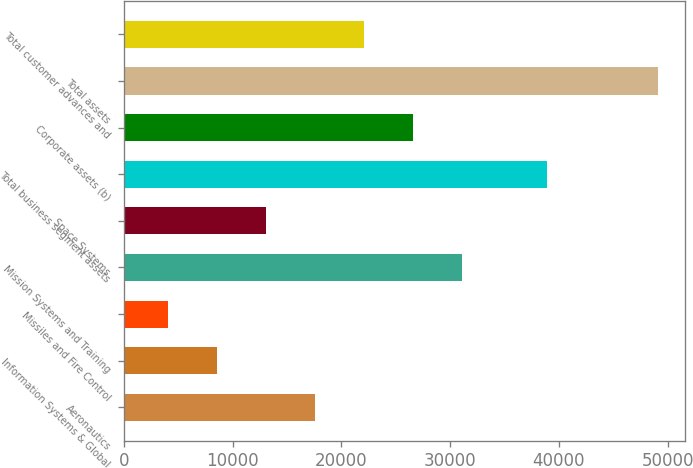Convert chart. <chart><loc_0><loc_0><loc_500><loc_500><bar_chart><fcel>Aeronautics<fcel>Information Systems & Global<fcel>Missiles and Fire Control<fcel>Mission Systems and Training<fcel>Space Systems<fcel>Total business segment assets<fcel>Corporate assets (b)<fcel>Total assets<fcel>Total customer advances and<nl><fcel>17557.3<fcel>8537.1<fcel>4027<fcel>31087.6<fcel>13047.2<fcel>38899<fcel>26577.5<fcel>49128<fcel>22067.4<nl></chart> 